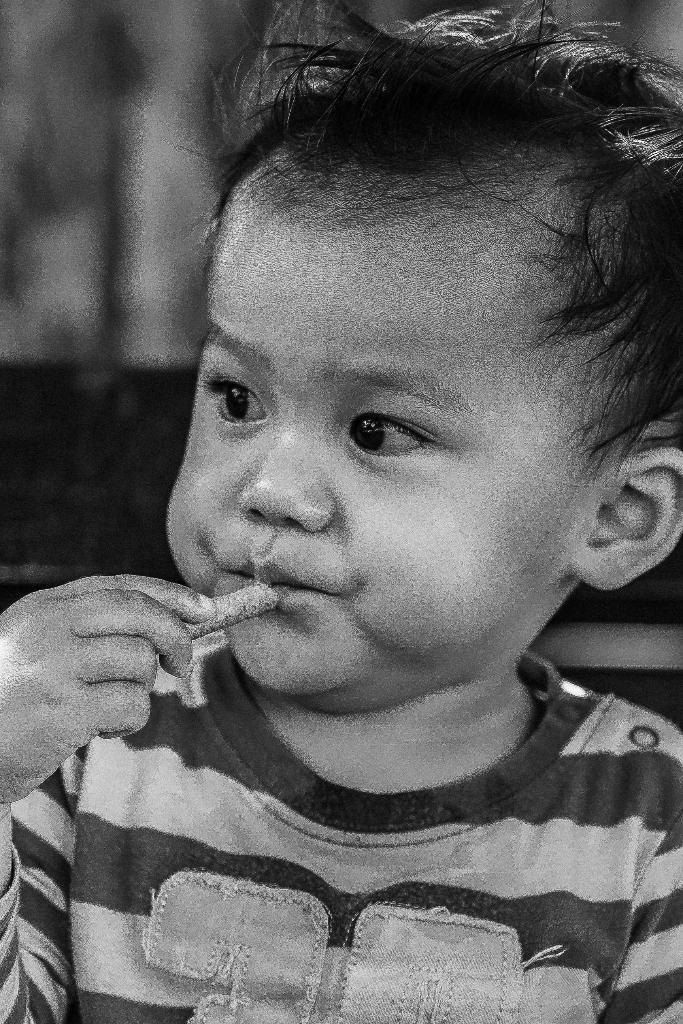What is the main subject of the image? The main subject of the image is a kid. What is the kid doing in the image? The kid is holding something in his hands. What type of grain can be seen growing in the image? There is no grain visible in the image; it features a kid holding something in his hands. How many cakes can be seen on the table in the image? There is no table or cakes present in the image. 